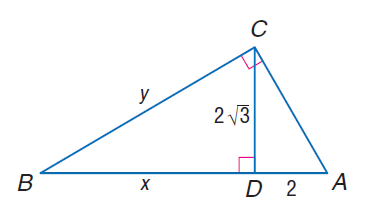Question: Find x.
Choices:
A. 3
B. 2 \sqrt { 3 }
C. 6
D. 4 \sqrt { 3 }
Answer with the letter. Answer: C Question: Find y.
Choices:
A. 2 \sqrt { 3 }
B. 4
C. 4 \sqrt { 3 }
D. 8
Answer with the letter. Answer: C 